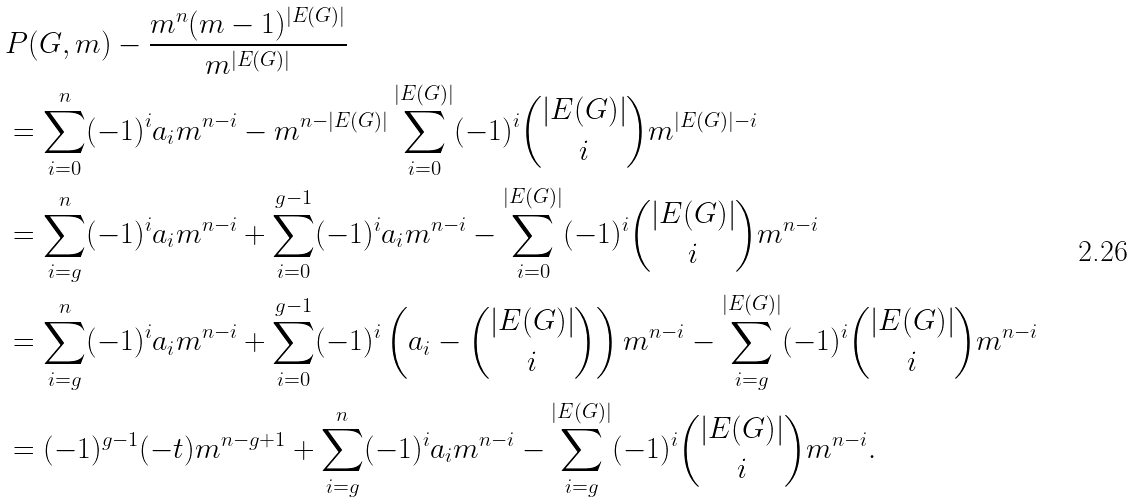Convert formula to latex. <formula><loc_0><loc_0><loc_500><loc_500>& P ( G , m ) - \frac { m ^ { n } ( m - 1 ) ^ { | E ( G ) | } } { m ^ { | E ( G ) | } } \\ & = \sum _ { i = 0 } ^ { n } ( - 1 ) ^ { i } a _ { i } m ^ { n - i } - m ^ { n - | E ( G ) | } \sum _ { i = 0 } ^ { | E ( G ) | } ( - 1 ) ^ { i } \binom { | E ( G ) | } { i } m ^ { | E ( G ) | - i } \\ & = \sum _ { i = g } ^ { n } ( - 1 ) ^ { i } a _ { i } m ^ { n - i } + \sum _ { i = 0 } ^ { g - 1 } ( - 1 ) ^ { i } a _ { i } m ^ { n - i } - \sum _ { i = 0 } ^ { | E ( G ) | } ( - 1 ) ^ { i } \binom { | E ( G ) | } { i } m ^ { n - i } \\ & = \sum _ { i = g } ^ { n } ( - 1 ) ^ { i } a _ { i } m ^ { n - i } + \sum _ { i = 0 } ^ { g - 1 } ( - 1 ) ^ { i } \left ( a _ { i } - \binom { | E ( G ) | } { i } \right ) m ^ { n - i } - \sum _ { i = g } ^ { | E ( G ) | } ( - 1 ) ^ { i } \binom { | E ( G ) | } { i } m ^ { n - i } \\ & = ( - 1 ) ^ { g - 1 } ( - t ) m ^ { n - g + 1 } + \sum _ { i = g } ^ { n } ( - 1 ) ^ { i } a _ { i } m ^ { n - i } - \sum _ { i = g } ^ { | E ( G ) | } ( - 1 ) ^ { i } \binom { | E ( G ) | } { i } m ^ { n - i } .</formula> 